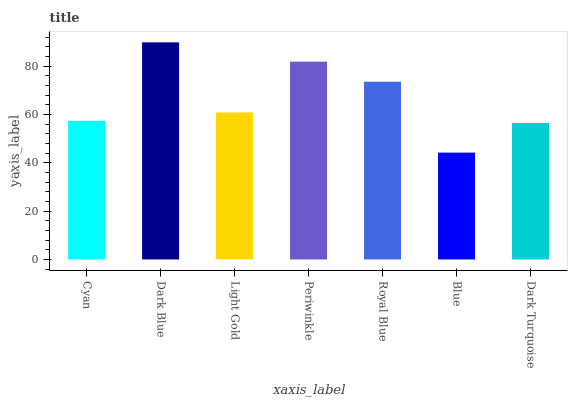Is Light Gold the minimum?
Answer yes or no. No. Is Light Gold the maximum?
Answer yes or no. No. Is Dark Blue greater than Light Gold?
Answer yes or no. Yes. Is Light Gold less than Dark Blue?
Answer yes or no. Yes. Is Light Gold greater than Dark Blue?
Answer yes or no. No. Is Dark Blue less than Light Gold?
Answer yes or no. No. Is Light Gold the high median?
Answer yes or no. Yes. Is Light Gold the low median?
Answer yes or no. Yes. Is Cyan the high median?
Answer yes or no. No. Is Periwinkle the low median?
Answer yes or no. No. 